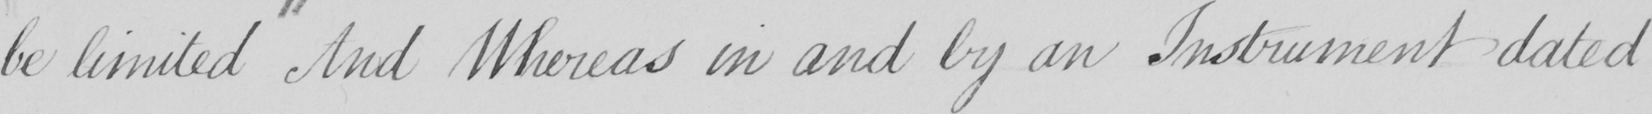What text is written in this handwritten line? be limited And Whereas in and by an Instrument dated 